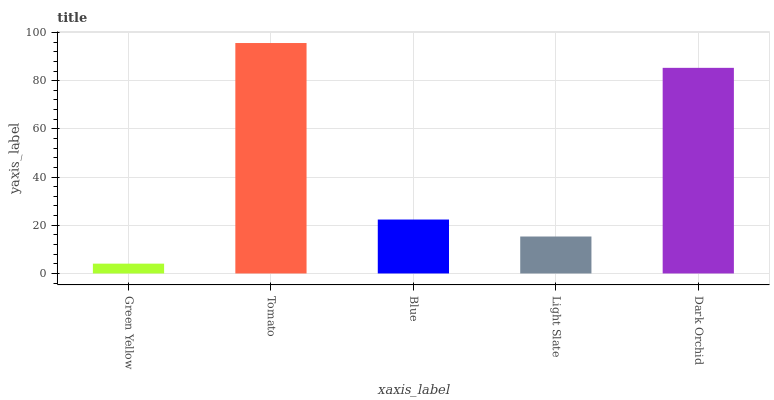Is Green Yellow the minimum?
Answer yes or no. Yes. Is Tomato the maximum?
Answer yes or no. Yes. Is Blue the minimum?
Answer yes or no. No. Is Blue the maximum?
Answer yes or no. No. Is Tomato greater than Blue?
Answer yes or no. Yes. Is Blue less than Tomato?
Answer yes or no. Yes. Is Blue greater than Tomato?
Answer yes or no. No. Is Tomato less than Blue?
Answer yes or no. No. Is Blue the high median?
Answer yes or no. Yes. Is Blue the low median?
Answer yes or no. Yes. Is Tomato the high median?
Answer yes or no. No. Is Tomato the low median?
Answer yes or no. No. 